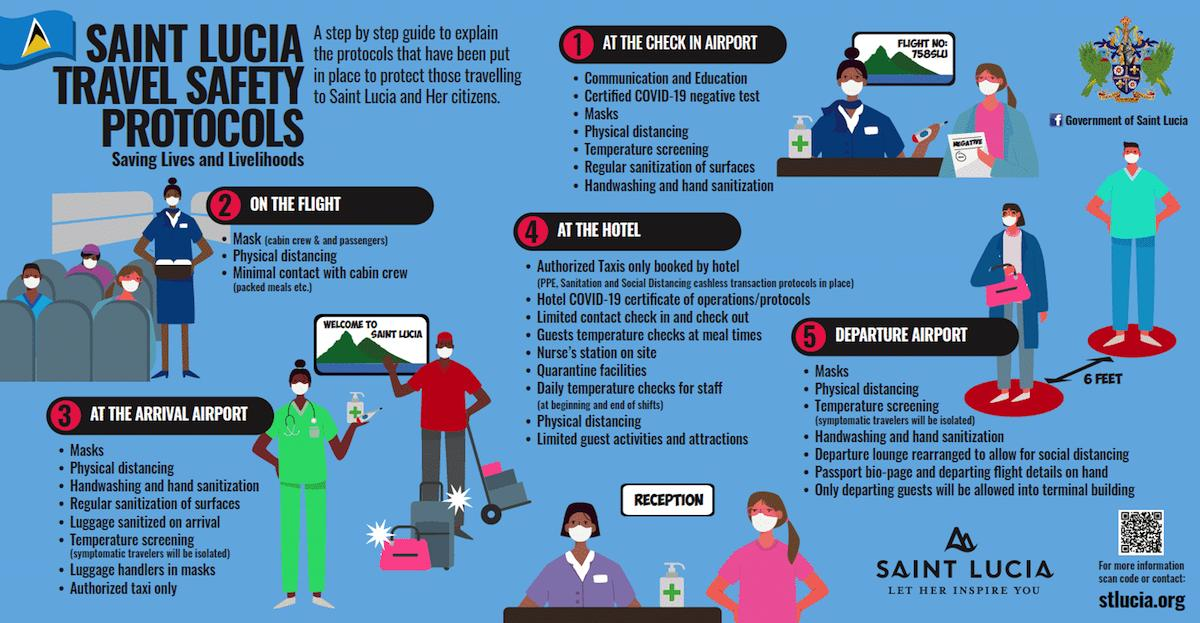Give some essential details in this illustration. Upon arriving at the airport, the first two protocols implemented are communication and education, both of which are certified COVID-19 negative. It is imperative that a nurse's station be made available on site at the hotel. The three safety protocols followed on flights are the use of masks, physical distancing, and minimal contact with cabin crew to minimize the risk of COVID-19 transmission. It is mandated by the travel protocols that a quarantine facility be provided at a hotel for the purpose of ensuring the health and safety of individuals traveling. Departure airport guests are only allowed to enter the terminal building for the purpose of departing. 